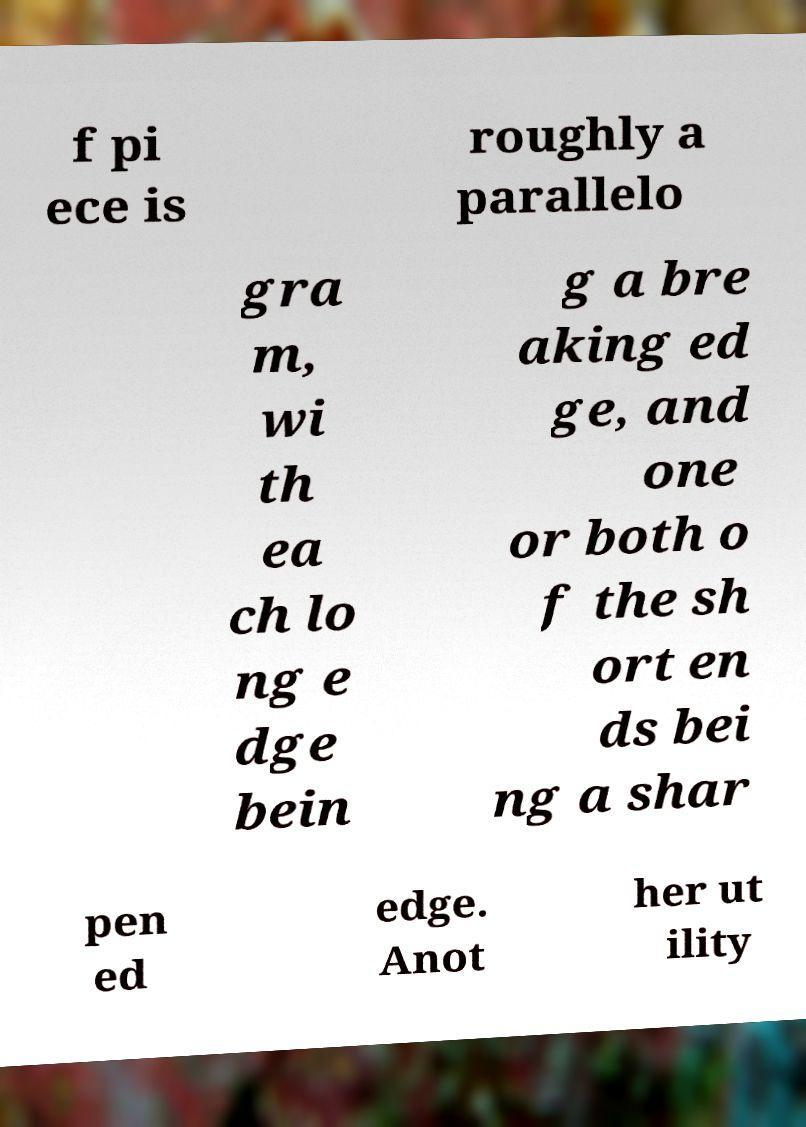Can you read and provide the text displayed in the image?This photo seems to have some interesting text. Can you extract and type it out for me? f pi ece is roughly a parallelo gra m, wi th ea ch lo ng e dge bein g a bre aking ed ge, and one or both o f the sh ort en ds bei ng a shar pen ed edge. Anot her ut ility 